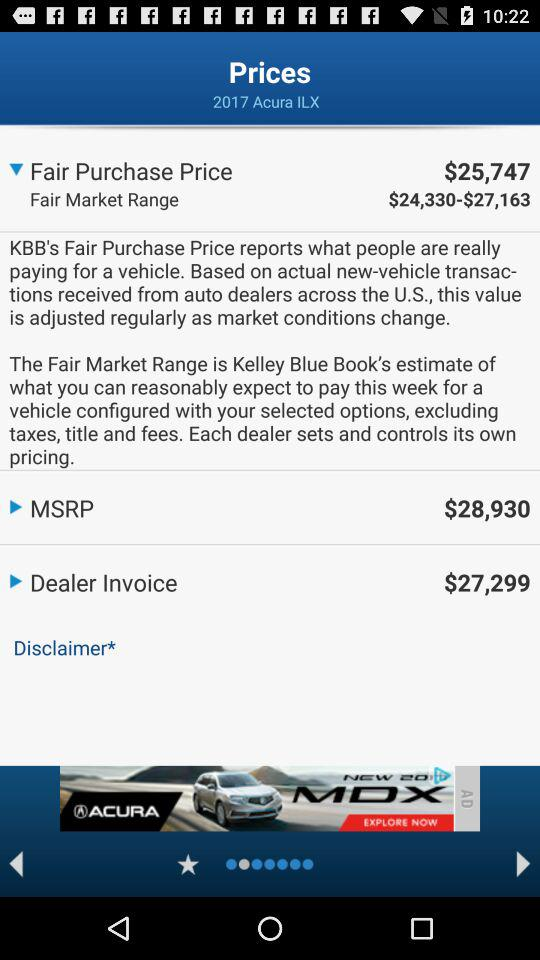What is the dealer invoice price? The dealer invoice price is $27,299. 